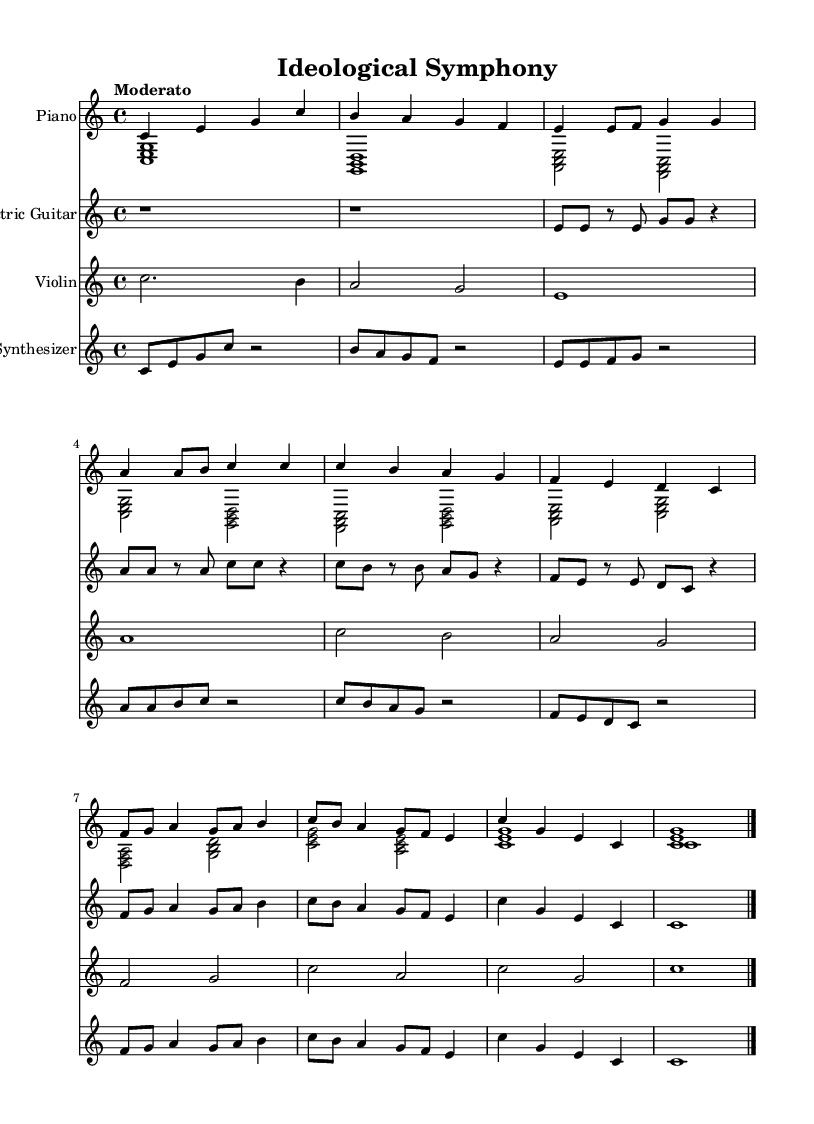What is the key signature of this music? The key signature is indicated at the beginning of the sheet music. In this case, it shows no sharps or flats, which means it is in C major.
Answer: C major What is the time signature of the score? The time signature is located at the beginning of the sheet music. Here, it is written as 4/4, indicating four beats per measure.
Answer: 4/4 What is the tempo marking for this piece? The tempo marking appears at the start of the score, and it indicates the speed of the music. In this case, it reads "Moderato," which suggests a moderate tempo.
Answer: Moderato How many instruments are featured in this composition? By counting the distinct staves, we can determine the number of instruments. There are four staves present: Piano, Electric Guitar, Violin, and Synthesizer.
Answer: Four Which instrument plays the highest pitch in this score? To find the instrument with the highest pitch, we analyze the ranges of the instruments listed. The Violin typically plays in a higher range compared to the others.
Answer: Violin What is the rhythmic pattern of the electric guitar in the first measure? The electric guitar's first measure has rest notes represented by "r," followed by a series of eighth notes (e, e). This sets a contrasting rhythmic pattern against the other instruments.
Answer: Rest and eighth notes How does the synthesizer relate to the overall fusion style? The synthesizer incorporates electronic elements while following the harmonic structure established by classical motifs in the piano and violin. This blend exemplifies the fusion of classical and contemporary styles.
Answer: Electronic and classical blend 